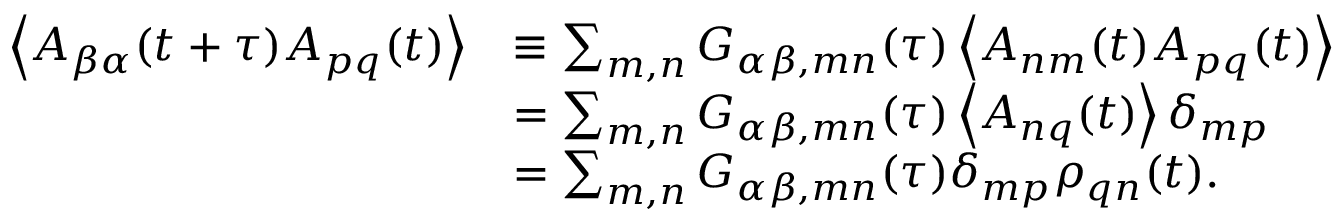Convert formula to latex. <formula><loc_0><loc_0><loc_500><loc_500>\begin{array} { r l } { \left \langle A _ { \beta \alpha } ( t + \tau ) A _ { p q } ( t ) \right \rangle } & { \equiv \sum _ { m , n } G _ { \alpha \beta , m n } ( \tau ) \left \langle A _ { n m } ( t ) A _ { p q } ( t ) \right \rangle } \\ & { = \sum _ { m , n } G _ { \alpha \beta , m n } ( \tau ) \left \langle A _ { n q } ( t ) \right \rangle \delta _ { m p } } \\ & { = \sum _ { m , n } G _ { \alpha \beta , m n } ( \tau ) \delta _ { m p } \rho _ { q n } ( t ) . } \end{array}</formula> 